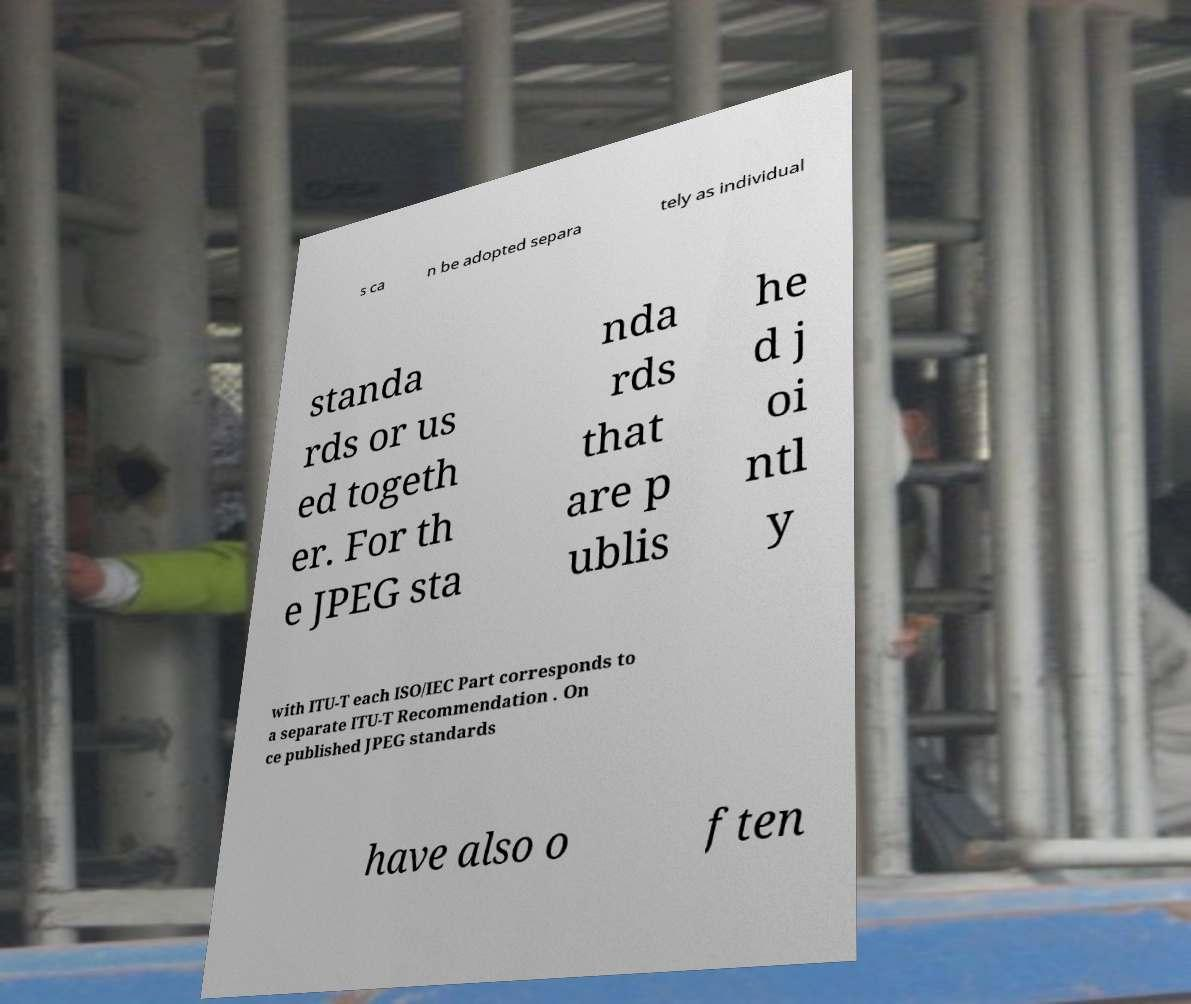Please read and relay the text visible in this image. What does it say? s ca n be adopted separa tely as individual standa rds or us ed togeth er. For th e JPEG sta nda rds that are p ublis he d j oi ntl y with ITU-T each ISO/IEC Part corresponds to a separate ITU-T Recommendation . On ce published JPEG standards have also o ften 